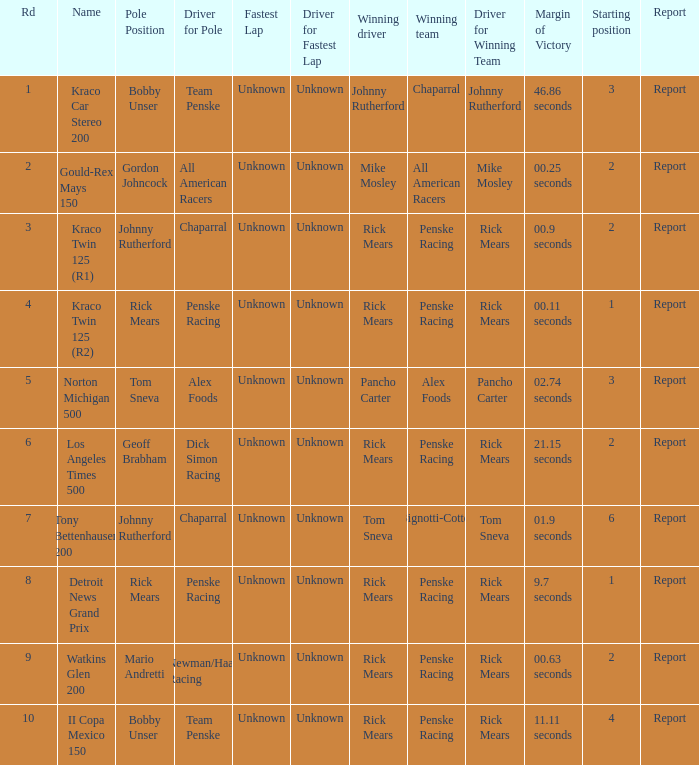How many fastest laps were there for a rd that equals 10? 1.0. 